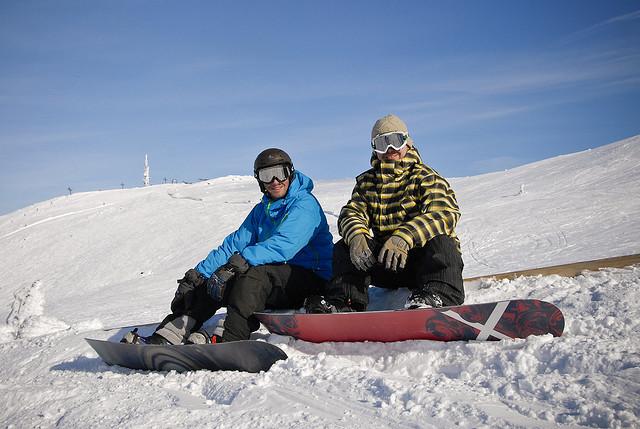How many people are shown?
Give a very brief answer. 2. Are they wearing winter clothing?
Concise answer only. Yes. How many people have gray goggles?
Answer briefly. 2. What is the temperature there?
Write a very short answer. Cold. 